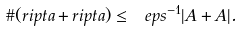Convert formula to latex. <formula><loc_0><loc_0><loc_500><loc_500>\# ( r i p t a + r i p t a ) \leq \ e p s ^ { - 1 } | A + A | .</formula> 